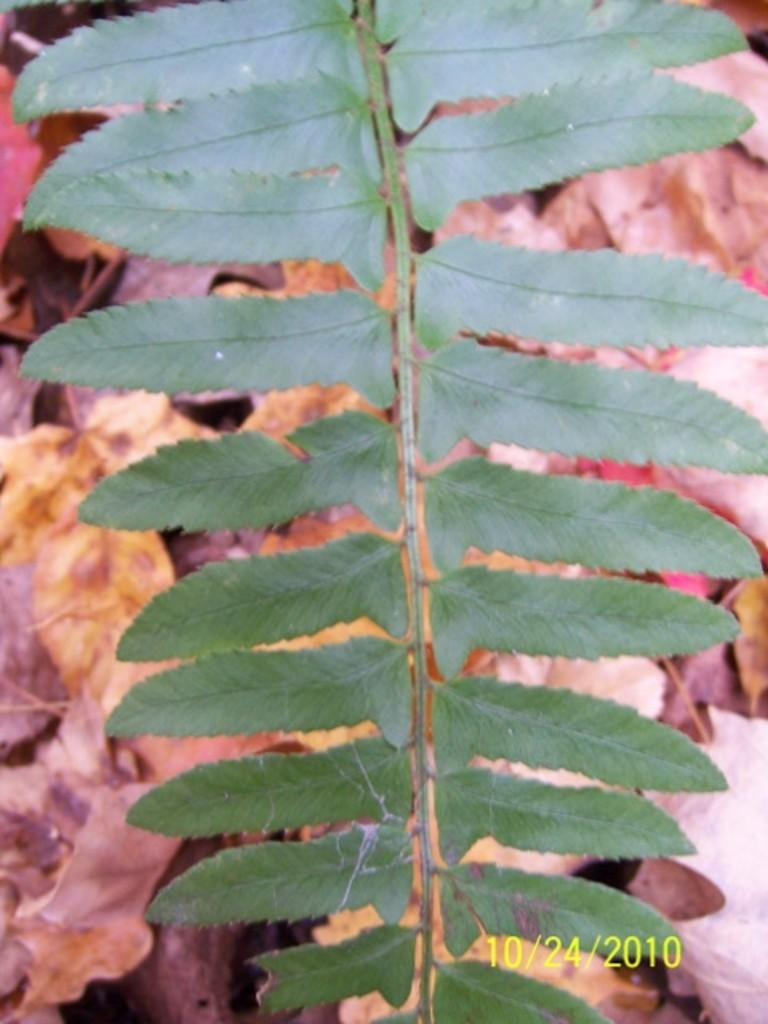What type of plant is represented in the image? There is a stem with green leaves in the image. What can be seen on the ground in the image? There are dried leaves on a path in the image. What type of battle is taking place in the image? There is no battle present in the image; it features a stem with green leaves and dried leaves on a path. What is the texture of the camera in the image? There is no camera present in the image. 